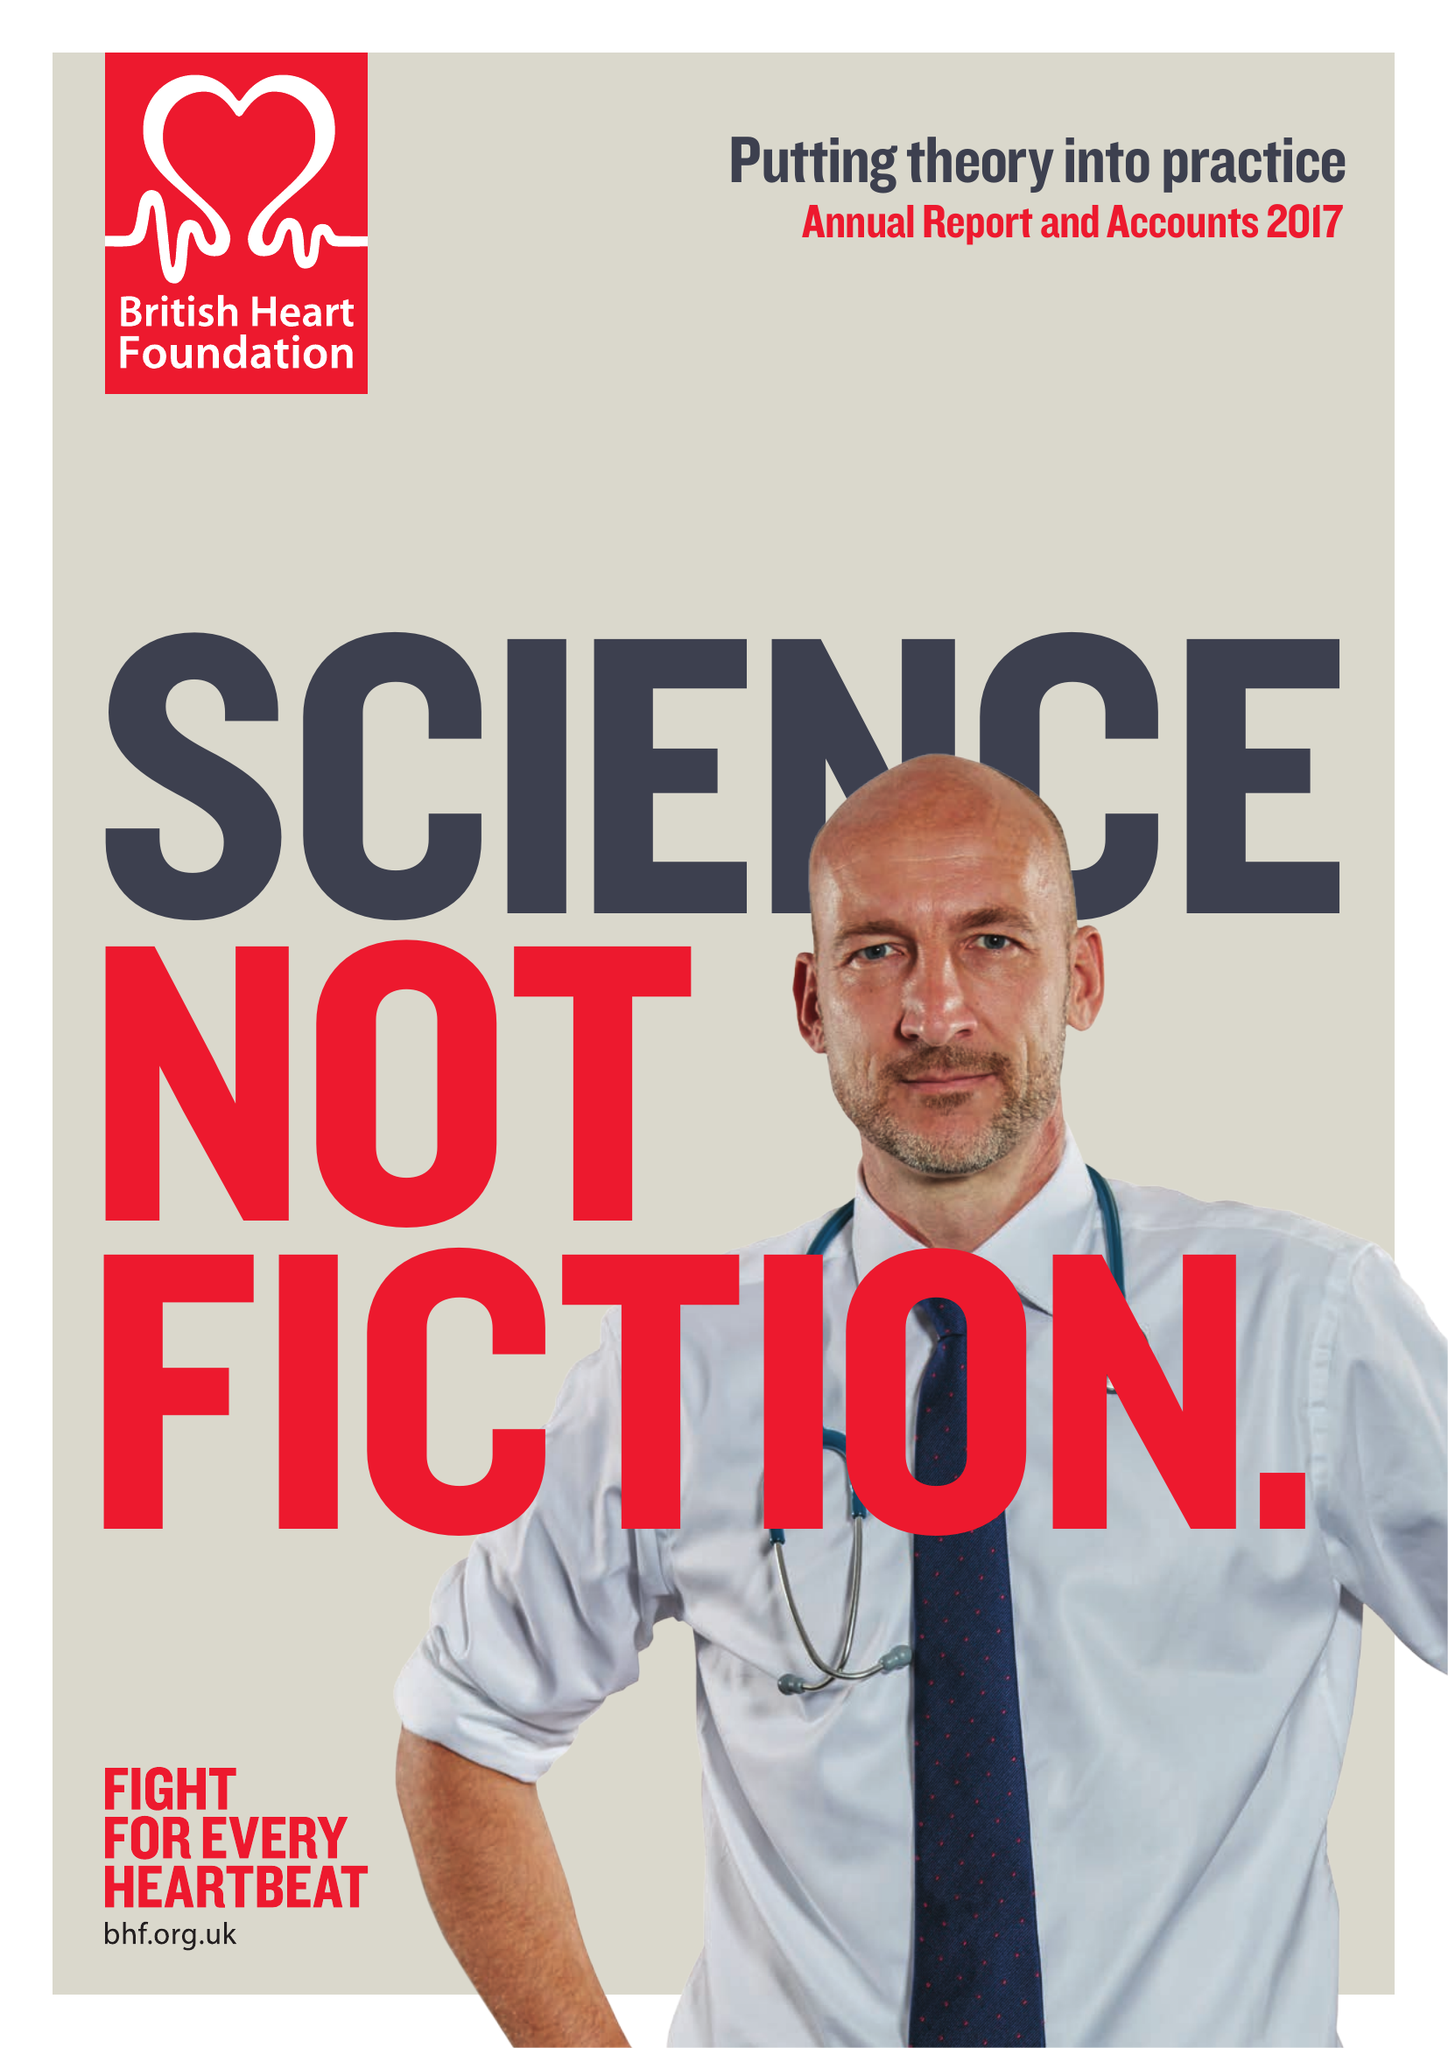What is the value for the address__post_town?
Answer the question using a single word or phrase. LONDON 